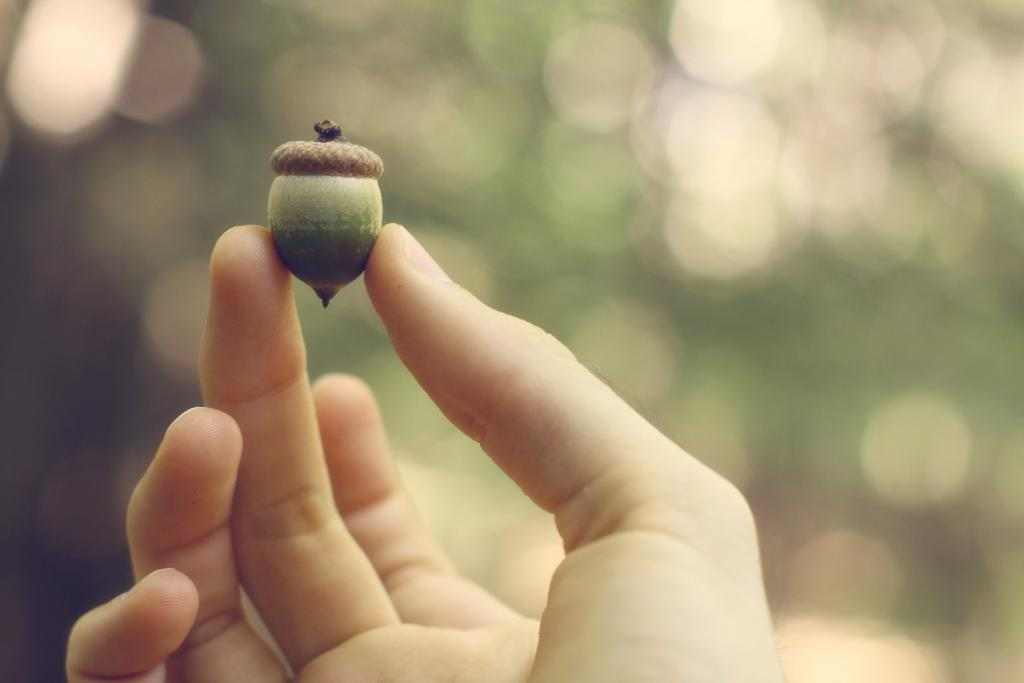What can be seen in the person's hand in the image? There is a nut in the person's hand in the image. Can you describe the background of the image? The background of the image is blurry. What type of ticket is the person holding in the image? There is no ticket present in the image; it only shows a person's hand holding a nut. What color is the vest that the person is wearing in the image? There is no vest visible in the image, as it only shows a person's hand holding a nut. 